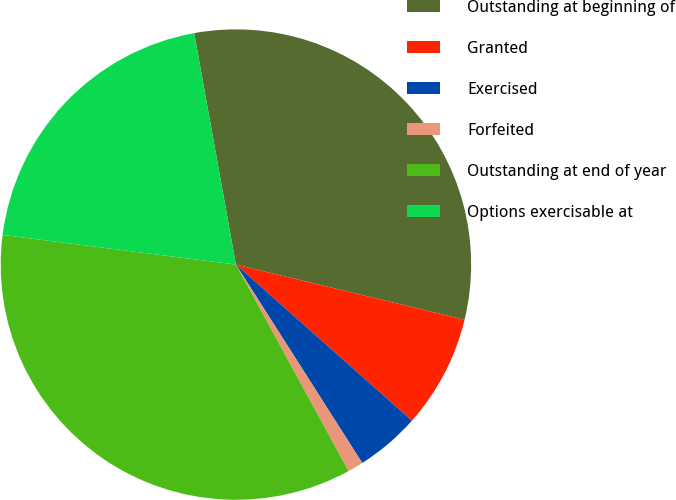Convert chart to OTSL. <chart><loc_0><loc_0><loc_500><loc_500><pie_chart><fcel>Outstanding at beginning of<fcel>Granted<fcel>Exercised<fcel>Forfeited<fcel>Outstanding at end of year<fcel>Options exercisable at<nl><fcel>31.61%<fcel>7.78%<fcel>4.43%<fcel>1.08%<fcel>34.96%<fcel>20.15%<nl></chart> 